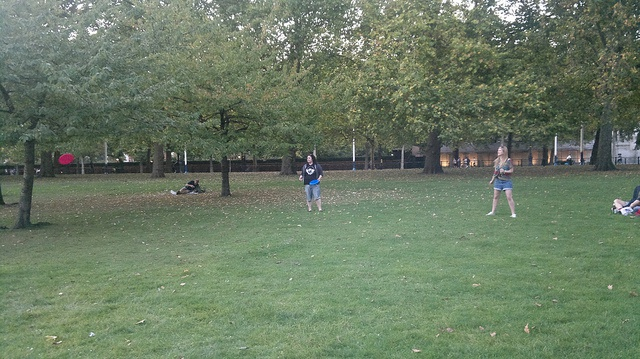Describe the objects in this image and their specific colors. I can see people in darkgray and gray tones, people in darkgray, gray, and black tones, people in darkgray, gray, blue, and lightgray tones, people in darkgray, gray, black, and purple tones, and frisbee in darkgray, brown, black, gray, and purple tones in this image. 